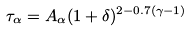Convert formula to latex. <formula><loc_0><loc_0><loc_500><loc_500>\tau _ { \alpha } = A _ { \alpha } ( 1 + \delta ) ^ { 2 - 0 . 7 ( \gamma - 1 ) }</formula> 